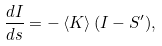Convert formula to latex. <formula><loc_0><loc_0><loc_500><loc_500>\frac { d I } { d s } = - \left \langle K \right \rangle ( I - S ^ { \prime } ) ,</formula> 